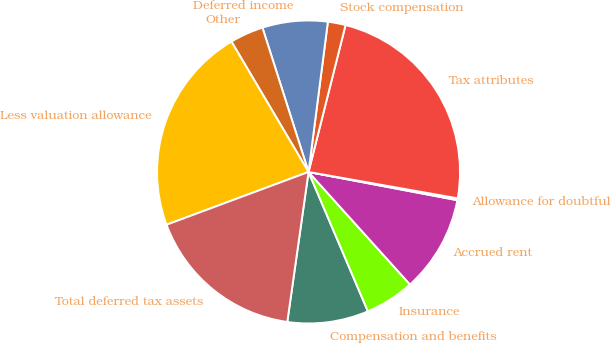Convert chart. <chart><loc_0><loc_0><loc_500><loc_500><pie_chart><fcel>Compensation and benefits<fcel>Insurance<fcel>Accrued rent<fcel>Allowance for doubtful<fcel>Tax attributes<fcel>Stock compensation<fcel>Deferred income<fcel>Other<fcel>Less valuation allowance<fcel>Total deferred tax assets<nl><fcel>8.65%<fcel>5.27%<fcel>10.34%<fcel>0.2%<fcel>23.86%<fcel>1.89%<fcel>6.96%<fcel>3.58%<fcel>22.17%<fcel>17.1%<nl></chart> 